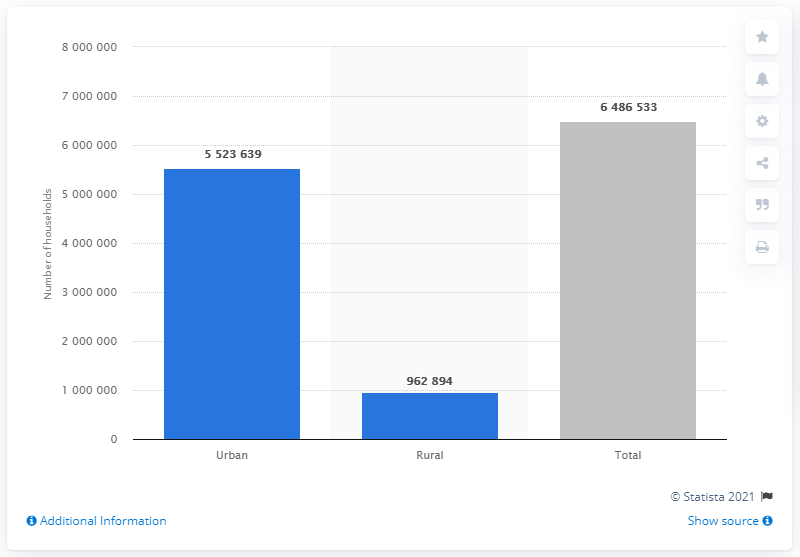Does the chart reflect any economic or social trends in Chile? Yes, the chart might reflect broader economic or social trends such as urbanization, migration patterns towards the cities for better job prospects, or access to services, and possibly a decline in traditional rural livelihoods. It could also indicate government investments favoring urban infrastructure and amenities. 